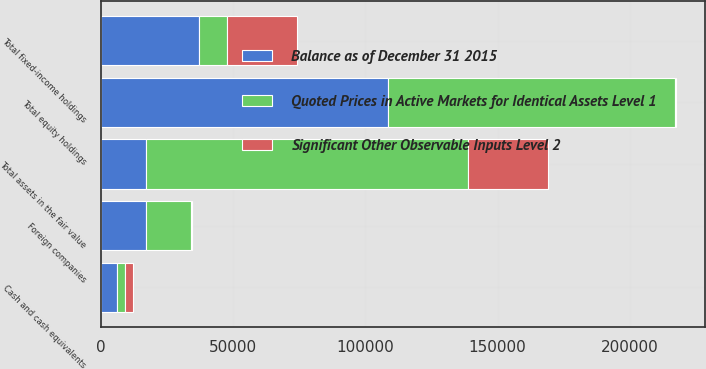<chart> <loc_0><loc_0><loc_500><loc_500><stacked_bar_chart><ecel><fcel>Cash and cash equivalents<fcel>Foreign companies<fcel>Total equity holdings<fcel>Total fixed-income holdings<fcel>Total assets in the fair value<nl><fcel>Balance as of December 31 2015<fcel>6068<fcel>17267<fcel>108771<fcel>37035<fcel>17058<nl><fcel>Quoted Prices in Active Markets for Identical Assets Level 1<fcel>2980<fcel>16849<fcel>108353<fcel>10531<fcel>121864<nl><fcel>Significant Other Observable Inputs Level 2<fcel>3088<fcel>418<fcel>418<fcel>26504<fcel>30010<nl></chart> 